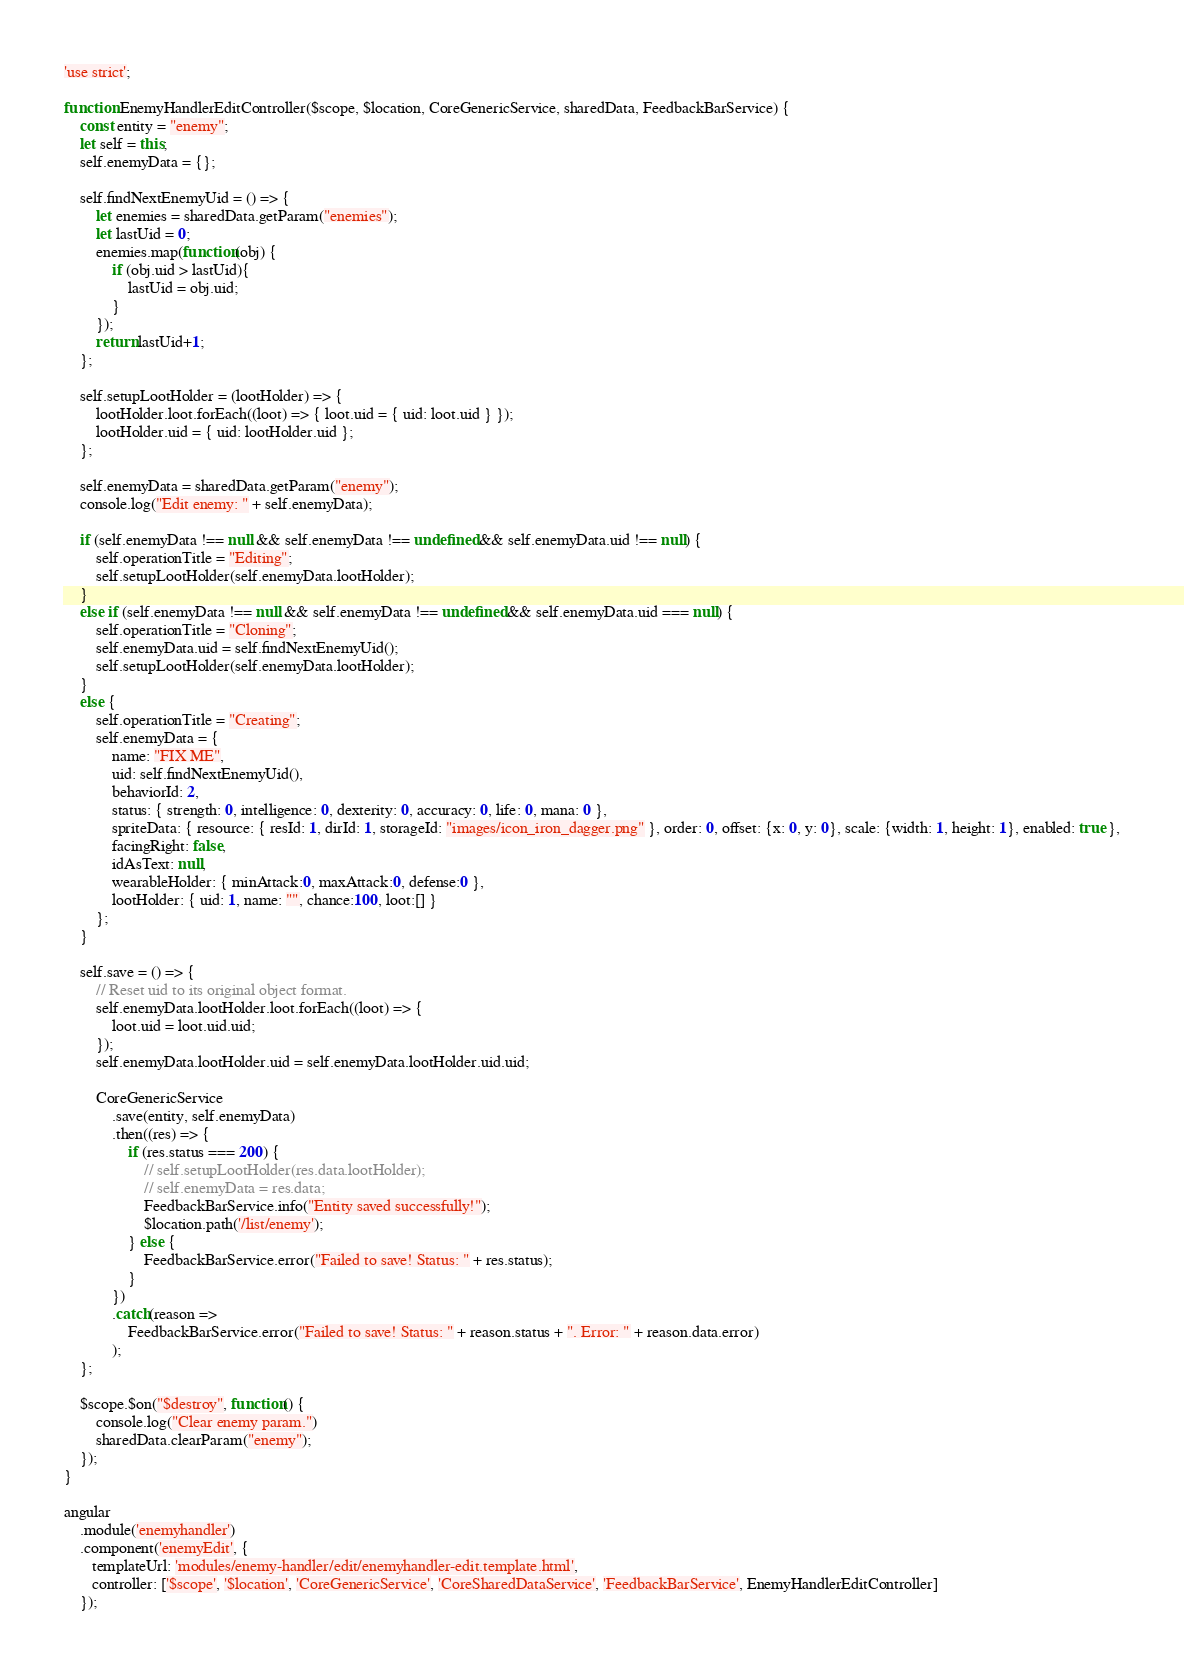Convert code to text. <code><loc_0><loc_0><loc_500><loc_500><_JavaScript_>'use strict';

function EnemyHandlerEditController($scope, $location, CoreGenericService, sharedData, FeedbackBarService) {
    const entity = "enemy";
    let self = this;
    self.enemyData = {};

    self.findNextEnemyUid = () => {
        let enemies = sharedData.getParam("enemies");
        let lastUid = 0;
        enemies.map(function(obj) {
            if (obj.uid > lastUid){
                lastUid = obj.uid;
            }
        });
        return lastUid+1;
    };

    self.setupLootHolder = (lootHolder) => {
        lootHolder.loot.forEach((loot) => { loot.uid = { uid: loot.uid } });
        lootHolder.uid = { uid: lootHolder.uid };
    };

    self.enemyData = sharedData.getParam("enemy");
    console.log("Edit enemy: " + self.enemyData);

    if (self.enemyData !== null && self.enemyData !== undefined && self.enemyData.uid !== null) {
        self.operationTitle = "Editing";
        self.setupLootHolder(self.enemyData.lootHolder);
    }
    else if (self.enemyData !== null && self.enemyData !== undefined && self.enemyData.uid === null) {
        self.operationTitle = "Cloning";
        self.enemyData.uid = self.findNextEnemyUid();
        self.setupLootHolder(self.enemyData.lootHolder);
    }
    else {
        self.operationTitle = "Creating";
        self.enemyData = {
            name: "FIX ME",
            uid: self.findNextEnemyUid(),
            behaviorId: 2,
            status: { strength: 0, intelligence: 0, dexterity: 0, accuracy: 0, life: 0, mana: 0 },
            spriteData: { resource: { resId: 1, dirId: 1, storageId: "images/icon_iron_dagger.png" }, order: 0, offset: {x: 0, y: 0}, scale: {width: 1, height: 1}, enabled: true },
            facingRight: false,
            idAsText: null,
            wearableHolder: { minAttack:0, maxAttack:0, defense:0 },
            lootHolder: { uid: 1, name: "", chance:100, loot:[] }
        };
    }

    self.save = () => {
        // Reset uid to its original object format.
        self.enemyData.lootHolder.loot.forEach((loot) => {
            loot.uid = loot.uid.uid;
        });
        self.enemyData.lootHolder.uid = self.enemyData.lootHolder.uid.uid;

        CoreGenericService
            .save(entity, self.enemyData)
            .then((res) => {
                if (res.status === 200) {
                    // self.setupLootHolder(res.data.lootHolder);
                    // self.enemyData = res.data;
                    FeedbackBarService.info("Entity saved successfully!");
                    $location.path('/list/enemy');
                } else {
                    FeedbackBarService.error("Failed to save! Status: " + res.status);
                }
            })
            .catch(reason =>
                FeedbackBarService.error("Failed to save! Status: " + reason.status + ". Error: " + reason.data.error)
            );
    };

    $scope.$on("$destroy", function() {
        console.log("Clear enemy param.")
        sharedData.clearParam("enemy");
    });
}

angular
    .module('enemyhandler')
    .component('enemyEdit', {
       templateUrl: 'modules/enemy-handler/edit/enemyhandler-edit.template.html',
       controller: ['$scope', '$location', 'CoreGenericService', 'CoreSharedDataService', 'FeedbackBarService', EnemyHandlerEditController]
    });
</code> 